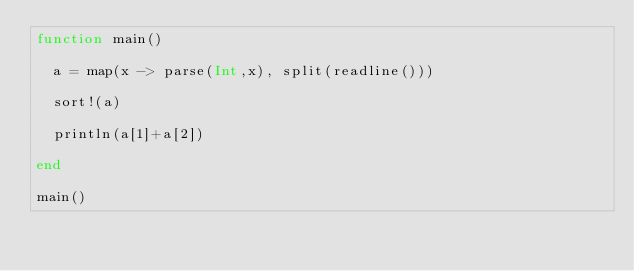Convert code to text. <code><loc_0><loc_0><loc_500><loc_500><_Julia_>function main()
  
  a = map(x -> parse(Int,x), split(readline()))
  
  sort!(a)
  
  println(a[1]+a[2])
  
end

main()</code> 